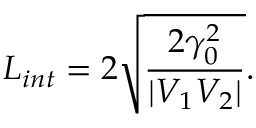Convert formula to latex. <formula><loc_0><loc_0><loc_500><loc_500>L _ { i n t } = 2 \sqrt { \frac { 2 \gamma _ { 0 } ^ { 2 } } { | V _ { 1 } V _ { 2 } | } } .</formula> 